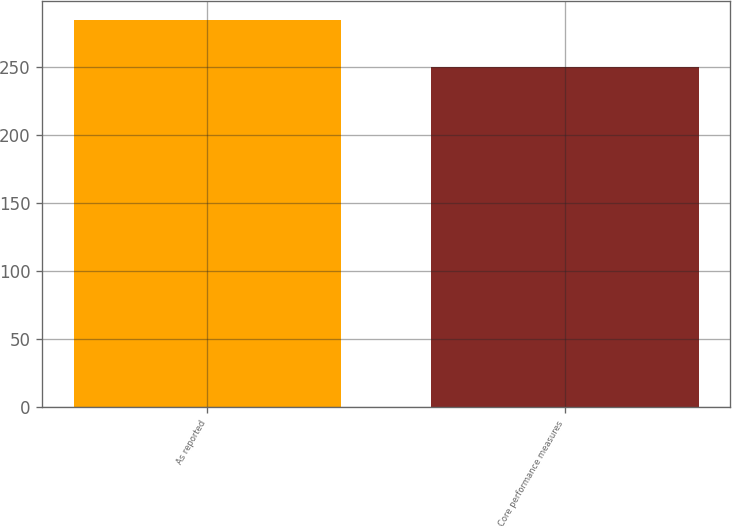<chart> <loc_0><loc_0><loc_500><loc_500><bar_chart><fcel>As reported<fcel>Core performance measures<nl><fcel>284<fcel>250<nl></chart> 